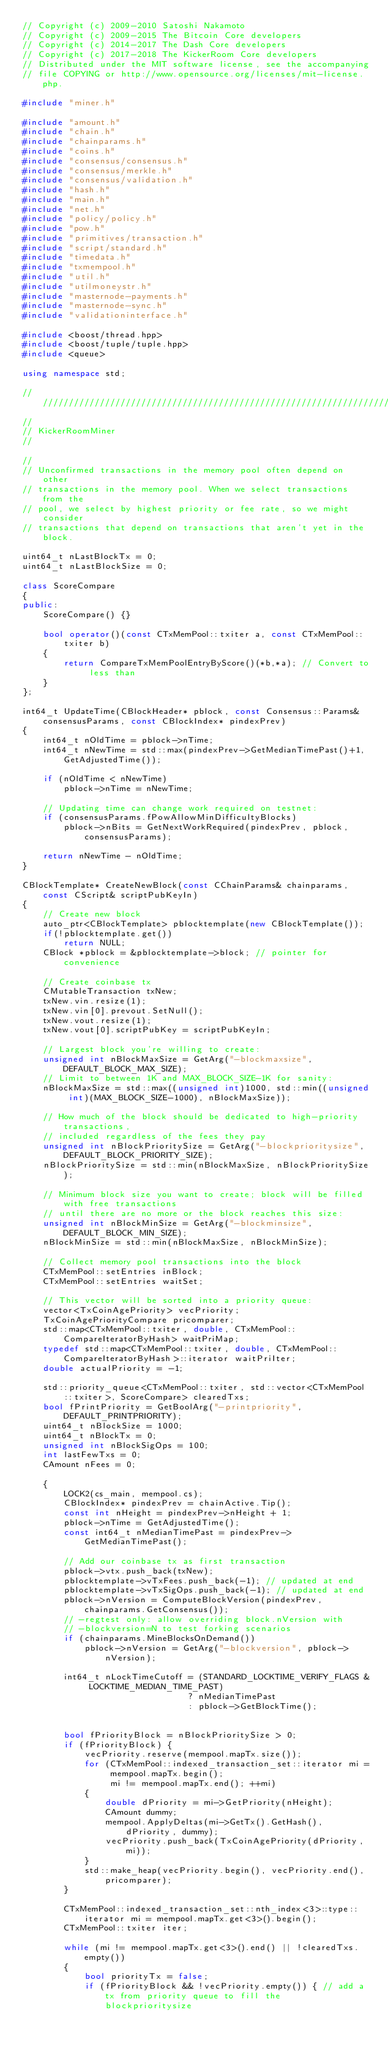<code> <loc_0><loc_0><loc_500><loc_500><_C++_>// Copyright (c) 2009-2010 Satoshi Nakamoto
// Copyright (c) 2009-2015 The Bitcoin Core developers
// Copyright (c) 2014-2017 The Dash Core developers
// Copyright (c) 2017-2018 The KickerRoom Core developers
// Distributed under the MIT software license, see the accompanying
// file COPYING or http://www.opensource.org/licenses/mit-license.php.

#include "miner.h"

#include "amount.h"
#include "chain.h"
#include "chainparams.h"
#include "coins.h"
#include "consensus/consensus.h"
#include "consensus/merkle.h"
#include "consensus/validation.h"
#include "hash.h"
#include "main.h"
#include "net.h"
#include "policy/policy.h"
#include "pow.h"
#include "primitives/transaction.h"
#include "script/standard.h"
#include "timedata.h"
#include "txmempool.h"
#include "util.h"
#include "utilmoneystr.h"
#include "masternode-payments.h"
#include "masternode-sync.h"
#include "validationinterface.h"

#include <boost/thread.hpp>
#include <boost/tuple/tuple.hpp>
#include <queue>

using namespace std;

//////////////////////////////////////////////////////////////////////////////
//
// KickerRoomMiner
//

//
// Unconfirmed transactions in the memory pool often depend on other
// transactions in the memory pool. When we select transactions from the
// pool, we select by highest priority or fee rate, so we might consider
// transactions that depend on transactions that aren't yet in the block.

uint64_t nLastBlockTx = 0;
uint64_t nLastBlockSize = 0;

class ScoreCompare
{
public:
    ScoreCompare() {}

    bool operator()(const CTxMemPool::txiter a, const CTxMemPool::txiter b)
    {
        return CompareTxMemPoolEntryByScore()(*b,*a); // Convert to less than
    }
};

int64_t UpdateTime(CBlockHeader* pblock, const Consensus::Params& consensusParams, const CBlockIndex* pindexPrev)
{
    int64_t nOldTime = pblock->nTime;
    int64_t nNewTime = std::max(pindexPrev->GetMedianTimePast()+1, GetAdjustedTime());

    if (nOldTime < nNewTime)
        pblock->nTime = nNewTime;

    // Updating time can change work required on testnet:
    if (consensusParams.fPowAllowMinDifficultyBlocks)
        pblock->nBits = GetNextWorkRequired(pindexPrev, pblock, consensusParams);

    return nNewTime - nOldTime;
}

CBlockTemplate* CreateNewBlock(const CChainParams& chainparams, const CScript& scriptPubKeyIn)
{
    // Create new block
    auto_ptr<CBlockTemplate> pblocktemplate(new CBlockTemplate());
    if(!pblocktemplate.get())
        return NULL;
    CBlock *pblock = &pblocktemplate->block; // pointer for convenience

    // Create coinbase tx
    CMutableTransaction txNew;
    txNew.vin.resize(1);
    txNew.vin[0].prevout.SetNull();
    txNew.vout.resize(1);
    txNew.vout[0].scriptPubKey = scriptPubKeyIn;

    // Largest block you're willing to create:
    unsigned int nBlockMaxSize = GetArg("-blockmaxsize", DEFAULT_BLOCK_MAX_SIZE);
    // Limit to between 1K and MAX_BLOCK_SIZE-1K for sanity:
    nBlockMaxSize = std::max((unsigned int)1000, std::min((unsigned int)(MAX_BLOCK_SIZE-1000), nBlockMaxSize));

    // How much of the block should be dedicated to high-priority transactions,
    // included regardless of the fees they pay
    unsigned int nBlockPrioritySize = GetArg("-blockprioritysize", DEFAULT_BLOCK_PRIORITY_SIZE);
    nBlockPrioritySize = std::min(nBlockMaxSize, nBlockPrioritySize);

    // Minimum block size you want to create; block will be filled with free transactions
    // until there are no more or the block reaches this size:
    unsigned int nBlockMinSize = GetArg("-blockminsize", DEFAULT_BLOCK_MIN_SIZE);
    nBlockMinSize = std::min(nBlockMaxSize, nBlockMinSize);

    // Collect memory pool transactions into the block
    CTxMemPool::setEntries inBlock;
    CTxMemPool::setEntries waitSet;

    // This vector will be sorted into a priority queue:
    vector<TxCoinAgePriority> vecPriority;
    TxCoinAgePriorityCompare pricomparer;
    std::map<CTxMemPool::txiter, double, CTxMemPool::CompareIteratorByHash> waitPriMap;
    typedef std::map<CTxMemPool::txiter, double, CTxMemPool::CompareIteratorByHash>::iterator waitPriIter;
    double actualPriority = -1;

    std::priority_queue<CTxMemPool::txiter, std::vector<CTxMemPool::txiter>, ScoreCompare> clearedTxs;
    bool fPrintPriority = GetBoolArg("-printpriority", DEFAULT_PRINTPRIORITY);
    uint64_t nBlockSize = 1000;
    uint64_t nBlockTx = 0;
    unsigned int nBlockSigOps = 100;
    int lastFewTxs = 0;
    CAmount nFees = 0;

    {
        LOCK2(cs_main, mempool.cs);
        CBlockIndex* pindexPrev = chainActive.Tip();
        const int nHeight = pindexPrev->nHeight + 1;
        pblock->nTime = GetAdjustedTime();
        const int64_t nMedianTimePast = pindexPrev->GetMedianTimePast();

        // Add our coinbase tx as first transaction
        pblock->vtx.push_back(txNew);
        pblocktemplate->vTxFees.push_back(-1); // updated at end
        pblocktemplate->vTxSigOps.push_back(-1); // updated at end
        pblock->nVersion = ComputeBlockVersion(pindexPrev, chainparams.GetConsensus());
        // -regtest only: allow overriding block.nVersion with
        // -blockversion=N to test forking scenarios
        if (chainparams.MineBlocksOnDemand())
            pblock->nVersion = GetArg("-blockversion", pblock->nVersion);

        int64_t nLockTimeCutoff = (STANDARD_LOCKTIME_VERIFY_FLAGS & LOCKTIME_MEDIAN_TIME_PAST)
                                ? nMedianTimePast
                                : pblock->GetBlockTime();


        bool fPriorityBlock = nBlockPrioritySize > 0;
        if (fPriorityBlock) {
            vecPriority.reserve(mempool.mapTx.size());
            for (CTxMemPool::indexed_transaction_set::iterator mi = mempool.mapTx.begin();
                 mi != mempool.mapTx.end(); ++mi)
            {
                double dPriority = mi->GetPriority(nHeight);
                CAmount dummy;
                mempool.ApplyDeltas(mi->GetTx().GetHash(), dPriority, dummy);
                vecPriority.push_back(TxCoinAgePriority(dPriority, mi));
            }
            std::make_heap(vecPriority.begin(), vecPriority.end(), pricomparer);
        }

        CTxMemPool::indexed_transaction_set::nth_index<3>::type::iterator mi = mempool.mapTx.get<3>().begin();
        CTxMemPool::txiter iter;

        while (mi != mempool.mapTx.get<3>().end() || !clearedTxs.empty())
        {
            bool priorityTx = false;
            if (fPriorityBlock && !vecPriority.empty()) { // add a tx from priority queue to fill the blockprioritysize</code> 